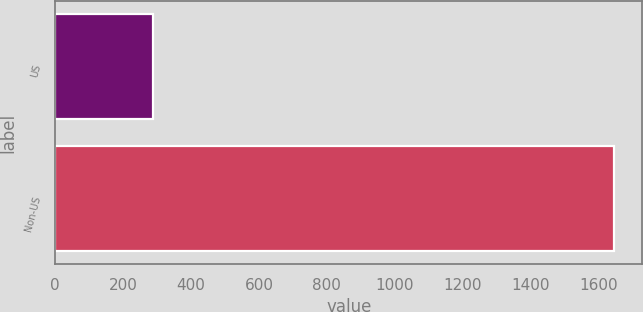Convert chart to OTSL. <chart><loc_0><loc_0><loc_500><loc_500><bar_chart><fcel>US<fcel>Non-US<nl><fcel>288<fcel>1647<nl></chart> 